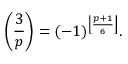Convert formula to latex. <formula><loc_0><loc_0><loc_500><loc_500>\left ( { \frac { 3 } { p } } \right ) = ( - 1 ) ^ { \left \lfloor { \frac { p + 1 } { 6 } } \right \rfloor } .</formula> 